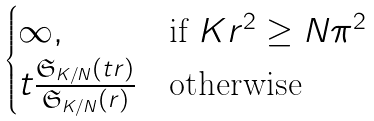Convert formula to latex. <formula><loc_0><loc_0><loc_500><loc_500>\begin{cases} \infty , & \text {if } K r ^ { 2 } \geq N \pi ^ { 2 } \\ t \frac { \mathfrak { S } _ { K / N } ( t r ) } { \mathfrak { S } _ { K / N } ( r ) } & \text {otherwise} \end{cases}</formula> 